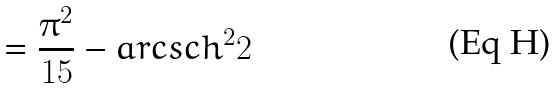<formula> <loc_0><loc_0><loc_500><loc_500>= \frac { \pi ^ { 2 } } { 1 5 } - a r c s c h ^ { 2 } 2</formula> 